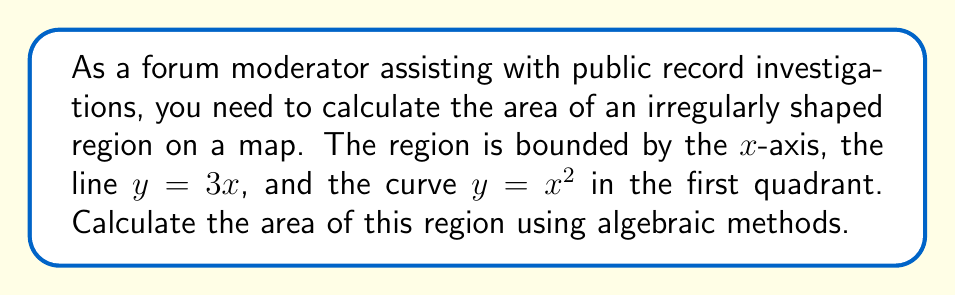Solve this math problem. To calculate the area of this irregularly shaped region, we'll use the following steps:

1) First, we need to find the points of intersection between the line $y = 3x$ and the curve $y = x^2$:

   $3x = x^2$
   $x^2 - 3x = 0$
   $x(x - 3) = 0$
   $x = 0$ or $x = 3$

   The point $(0,0)$ is on the x-axis, so we'll use $x = 3$.

2) The region is bounded by $y = 3x$ above and $y = x^2$ below. We can find the area by integrating the difference between these functions from $x = 0$ to $x = 3$:

   $$\text{Area} = \int_0^3 (3x - x^2) dx$$

3) Let's solve this integral:

   $$\begin{align*}
   \text{Area} &= \int_0^3 (3x - x^2) dx \\
   &= \left[\frac{3x^2}{2} - \frac{x^3}{3}\right]_0^3 \\
   &= \left(\frac{3(3^2)}{2} - \frac{3^3}{3}\right) - \left(\frac{3(0^2)}{2} - \frac{0^3}{3}\right) \\
   &= \left(\frac{27}{2} - 9\right) - 0 \\
   &= \frac{27}{2} - 9 \\
   &= \frac{27}{2} - \frac{18}{2} \\
   &= \frac{9}{2}
   \end{align*}$$

4) Therefore, the area of the irregularly shaped region is $\frac{9}{2}$ square units.
Answer: $\frac{9}{2}$ square units 